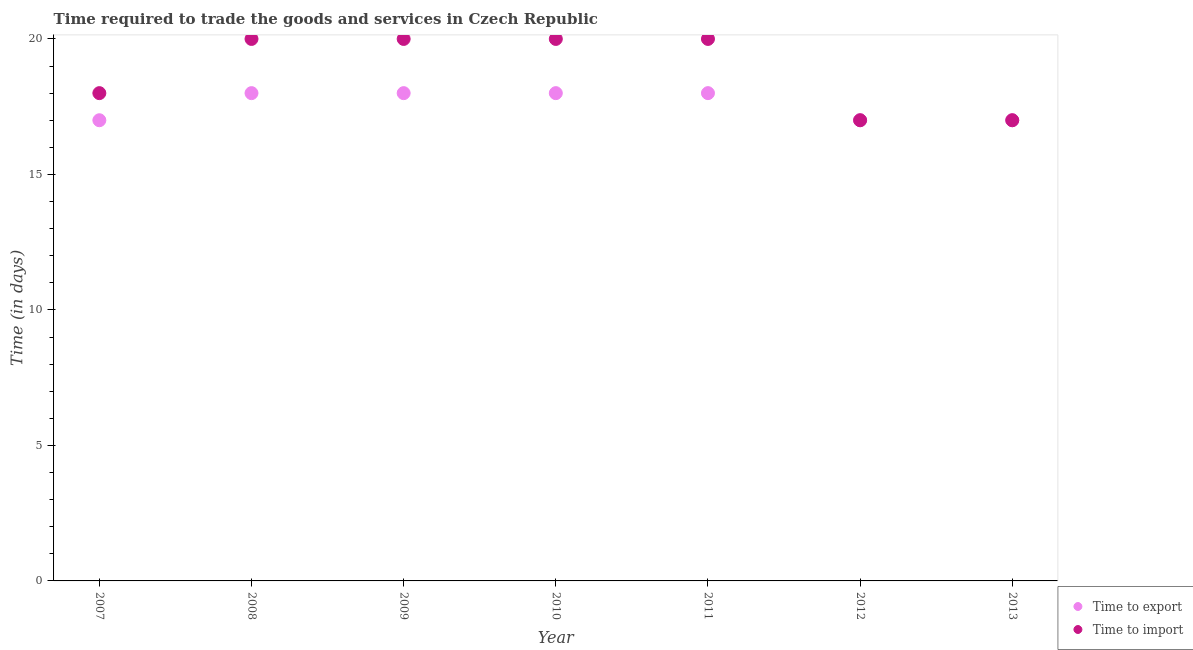How many different coloured dotlines are there?
Provide a short and direct response. 2. Is the number of dotlines equal to the number of legend labels?
Make the answer very short. Yes. What is the time to export in 2009?
Your response must be concise. 18. Across all years, what is the maximum time to export?
Offer a very short reply. 18. Across all years, what is the minimum time to import?
Your answer should be very brief. 17. What is the total time to import in the graph?
Your response must be concise. 132. What is the difference between the time to import in 2008 and that in 2013?
Ensure brevity in your answer.  3. What is the difference between the time to export in 2011 and the time to import in 2013?
Provide a short and direct response. 1. What is the average time to import per year?
Provide a succinct answer. 18.86. In the year 2011, what is the difference between the time to import and time to export?
Give a very brief answer. 2. In how many years, is the time to export greater than 14 days?
Your answer should be compact. 7. What is the ratio of the time to import in 2007 to that in 2012?
Offer a very short reply. 1.06. Is the difference between the time to import in 2009 and 2013 greater than the difference between the time to export in 2009 and 2013?
Offer a very short reply. Yes. What is the difference between the highest and the second highest time to export?
Your response must be concise. 0. What is the difference between the highest and the lowest time to import?
Ensure brevity in your answer.  3. In how many years, is the time to import greater than the average time to import taken over all years?
Offer a terse response. 4. Is the sum of the time to export in 2009 and 2010 greater than the maximum time to import across all years?
Your answer should be very brief. Yes. Is the time to import strictly greater than the time to export over the years?
Your answer should be very brief. No. Does the graph contain any zero values?
Make the answer very short. No. Where does the legend appear in the graph?
Your response must be concise. Bottom right. How many legend labels are there?
Your answer should be very brief. 2. What is the title of the graph?
Your answer should be compact. Time required to trade the goods and services in Czech Republic. What is the label or title of the Y-axis?
Your answer should be compact. Time (in days). What is the Time (in days) in Time to export in 2007?
Provide a succinct answer. 17. What is the Time (in days) in Time to import in 2007?
Keep it short and to the point. 18. What is the Time (in days) in Time to export in 2008?
Provide a short and direct response. 18. What is the Time (in days) in Time to export in 2009?
Offer a terse response. 18. What is the Time (in days) in Time to import in 2009?
Offer a terse response. 20. What is the Time (in days) in Time to export in 2010?
Give a very brief answer. 18. What is the Time (in days) of Time to export in 2011?
Offer a very short reply. 18. What is the Time (in days) in Time to export in 2012?
Give a very brief answer. 17. What is the Time (in days) in Time to import in 2012?
Provide a succinct answer. 17. Across all years, what is the maximum Time (in days) in Time to export?
Give a very brief answer. 18. What is the total Time (in days) in Time to export in the graph?
Give a very brief answer. 123. What is the total Time (in days) of Time to import in the graph?
Keep it short and to the point. 132. What is the difference between the Time (in days) of Time to export in 2007 and that in 2008?
Your answer should be very brief. -1. What is the difference between the Time (in days) in Time to import in 2007 and that in 2008?
Your answer should be compact. -2. What is the difference between the Time (in days) in Time to export in 2007 and that in 2009?
Your answer should be very brief. -1. What is the difference between the Time (in days) in Time to import in 2007 and that in 2009?
Your answer should be very brief. -2. What is the difference between the Time (in days) in Time to export in 2007 and that in 2011?
Your response must be concise. -1. What is the difference between the Time (in days) in Time to import in 2007 and that in 2011?
Your answer should be very brief. -2. What is the difference between the Time (in days) of Time to export in 2007 and that in 2012?
Make the answer very short. 0. What is the difference between the Time (in days) in Time to import in 2007 and that in 2012?
Your answer should be compact. 1. What is the difference between the Time (in days) of Time to import in 2007 and that in 2013?
Provide a succinct answer. 1. What is the difference between the Time (in days) in Time to export in 2008 and that in 2009?
Keep it short and to the point. 0. What is the difference between the Time (in days) in Time to import in 2008 and that in 2009?
Ensure brevity in your answer.  0. What is the difference between the Time (in days) of Time to export in 2008 and that in 2012?
Give a very brief answer. 1. What is the difference between the Time (in days) in Time to import in 2008 and that in 2013?
Offer a very short reply. 3. What is the difference between the Time (in days) of Time to export in 2009 and that in 2010?
Offer a terse response. 0. What is the difference between the Time (in days) of Time to import in 2009 and that in 2010?
Offer a terse response. 0. What is the difference between the Time (in days) of Time to export in 2009 and that in 2011?
Provide a short and direct response. 0. What is the difference between the Time (in days) in Time to export in 2009 and that in 2012?
Give a very brief answer. 1. What is the difference between the Time (in days) of Time to import in 2009 and that in 2013?
Your answer should be compact. 3. What is the difference between the Time (in days) of Time to export in 2010 and that in 2011?
Offer a terse response. 0. What is the difference between the Time (in days) in Time to export in 2010 and that in 2013?
Offer a terse response. 1. What is the difference between the Time (in days) in Time to import in 2010 and that in 2013?
Offer a terse response. 3. What is the difference between the Time (in days) of Time to export in 2011 and that in 2012?
Keep it short and to the point. 1. What is the difference between the Time (in days) of Time to import in 2011 and that in 2012?
Keep it short and to the point. 3. What is the difference between the Time (in days) of Time to export in 2011 and that in 2013?
Provide a short and direct response. 1. What is the difference between the Time (in days) of Time to import in 2012 and that in 2013?
Your response must be concise. 0. What is the difference between the Time (in days) in Time to export in 2007 and the Time (in days) in Time to import in 2008?
Provide a succinct answer. -3. What is the difference between the Time (in days) of Time to export in 2007 and the Time (in days) of Time to import in 2009?
Keep it short and to the point. -3. What is the difference between the Time (in days) in Time to export in 2007 and the Time (in days) in Time to import in 2010?
Provide a short and direct response. -3. What is the difference between the Time (in days) of Time to export in 2007 and the Time (in days) of Time to import in 2011?
Ensure brevity in your answer.  -3. What is the difference between the Time (in days) of Time to export in 2008 and the Time (in days) of Time to import in 2009?
Offer a very short reply. -2. What is the difference between the Time (in days) of Time to export in 2008 and the Time (in days) of Time to import in 2012?
Ensure brevity in your answer.  1. What is the difference between the Time (in days) in Time to export in 2008 and the Time (in days) in Time to import in 2013?
Provide a short and direct response. 1. What is the difference between the Time (in days) of Time to export in 2009 and the Time (in days) of Time to import in 2010?
Keep it short and to the point. -2. What is the difference between the Time (in days) in Time to export in 2010 and the Time (in days) in Time to import in 2011?
Keep it short and to the point. -2. What is the difference between the Time (in days) of Time to export in 2010 and the Time (in days) of Time to import in 2013?
Offer a terse response. 1. What is the difference between the Time (in days) of Time to export in 2011 and the Time (in days) of Time to import in 2013?
Ensure brevity in your answer.  1. What is the difference between the Time (in days) in Time to export in 2012 and the Time (in days) in Time to import in 2013?
Make the answer very short. 0. What is the average Time (in days) in Time to export per year?
Your response must be concise. 17.57. What is the average Time (in days) of Time to import per year?
Give a very brief answer. 18.86. In the year 2007, what is the difference between the Time (in days) in Time to export and Time (in days) in Time to import?
Your response must be concise. -1. In the year 2008, what is the difference between the Time (in days) in Time to export and Time (in days) in Time to import?
Make the answer very short. -2. In the year 2009, what is the difference between the Time (in days) of Time to export and Time (in days) of Time to import?
Give a very brief answer. -2. In the year 2011, what is the difference between the Time (in days) in Time to export and Time (in days) in Time to import?
Your response must be concise. -2. In the year 2012, what is the difference between the Time (in days) in Time to export and Time (in days) in Time to import?
Keep it short and to the point. 0. In the year 2013, what is the difference between the Time (in days) of Time to export and Time (in days) of Time to import?
Give a very brief answer. 0. What is the ratio of the Time (in days) in Time to export in 2007 to that in 2008?
Your answer should be very brief. 0.94. What is the ratio of the Time (in days) in Time to import in 2007 to that in 2008?
Make the answer very short. 0.9. What is the ratio of the Time (in days) in Time to export in 2007 to that in 2009?
Give a very brief answer. 0.94. What is the ratio of the Time (in days) of Time to import in 2007 to that in 2009?
Offer a very short reply. 0.9. What is the ratio of the Time (in days) in Time to export in 2007 to that in 2010?
Your answer should be very brief. 0.94. What is the ratio of the Time (in days) in Time to import in 2007 to that in 2010?
Provide a succinct answer. 0.9. What is the ratio of the Time (in days) of Time to export in 2007 to that in 2011?
Give a very brief answer. 0.94. What is the ratio of the Time (in days) of Time to import in 2007 to that in 2011?
Your response must be concise. 0.9. What is the ratio of the Time (in days) of Time to export in 2007 to that in 2012?
Your response must be concise. 1. What is the ratio of the Time (in days) of Time to import in 2007 to that in 2012?
Your response must be concise. 1.06. What is the ratio of the Time (in days) in Time to export in 2007 to that in 2013?
Provide a short and direct response. 1. What is the ratio of the Time (in days) of Time to import in 2007 to that in 2013?
Your answer should be compact. 1.06. What is the ratio of the Time (in days) of Time to export in 2008 to that in 2009?
Ensure brevity in your answer.  1. What is the ratio of the Time (in days) of Time to import in 2008 to that in 2009?
Offer a terse response. 1. What is the ratio of the Time (in days) in Time to export in 2008 to that in 2011?
Give a very brief answer. 1. What is the ratio of the Time (in days) of Time to import in 2008 to that in 2011?
Your answer should be very brief. 1. What is the ratio of the Time (in days) of Time to export in 2008 to that in 2012?
Offer a very short reply. 1.06. What is the ratio of the Time (in days) in Time to import in 2008 to that in 2012?
Provide a succinct answer. 1.18. What is the ratio of the Time (in days) of Time to export in 2008 to that in 2013?
Your answer should be very brief. 1.06. What is the ratio of the Time (in days) in Time to import in 2008 to that in 2013?
Keep it short and to the point. 1.18. What is the ratio of the Time (in days) in Time to export in 2009 to that in 2010?
Provide a succinct answer. 1. What is the ratio of the Time (in days) of Time to export in 2009 to that in 2011?
Offer a very short reply. 1. What is the ratio of the Time (in days) of Time to import in 2009 to that in 2011?
Ensure brevity in your answer.  1. What is the ratio of the Time (in days) of Time to export in 2009 to that in 2012?
Your answer should be very brief. 1.06. What is the ratio of the Time (in days) in Time to import in 2009 to that in 2012?
Your response must be concise. 1.18. What is the ratio of the Time (in days) of Time to export in 2009 to that in 2013?
Your answer should be very brief. 1.06. What is the ratio of the Time (in days) in Time to import in 2009 to that in 2013?
Give a very brief answer. 1.18. What is the ratio of the Time (in days) in Time to import in 2010 to that in 2011?
Your response must be concise. 1. What is the ratio of the Time (in days) of Time to export in 2010 to that in 2012?
Ensure brevity in your answer.  1.06. What is the ratio of the Time (in days) in Time to import in 2010 to that in 2012?
Your answer should be very brief. 1.18. What is the ratio of the Time (in days) of Time to export in 2010 to that in 2013?
Your answer should be compact. 1.06. What is the ratio of the Time (in days) of Time to import in 2010 to that in 2013?
Provide a short and direct response. 1.18. What is the ratio of the Time (in days) of Time to export in 2011 to that in 2012?
Provide a succinct answer. 1.06. What is the ratio of the Time (in days) in Time to import in 2011 to that in 2012?
Make the answer very short. 1.18. What is the ratio of the Time (in days) of Time to export in 2011 to that in 2013?
Ensure brevity in your answer.  1.06. What is the ratio of the Time (in days) in Time to import in 2011 to that in 2013?
Offer a terse response. 1.18. What is the difference between the highest and the second highest Time (in days) in Time to export?
Keep it short and to the point. 0. What is the difference between the highest and the second highest Time (in days) in Time to import?
Offer a terse response. 0. What is the difference between the highest and the lowest Time (in days) in Time to export?
Offer a terse response. 1. 